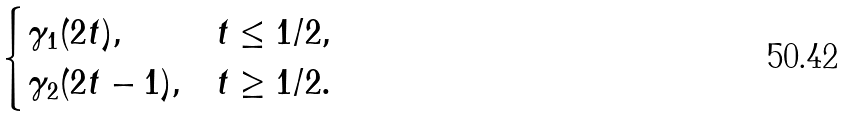Convert formula to latex. <formula><loc_0><loc_0><loc_500><loc_500>\begin{cases} \gamma _ { 1 } ( 2 t ) , & t \leq 1 / 2 , \\ \gamma _ { 2 } ( 2 t - 1 ) , & t \geq 1 / 2 . \end{cases}</formula> 